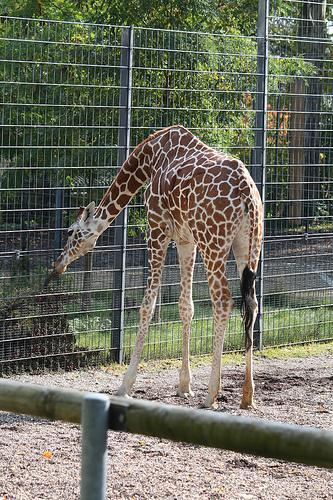Question: when was the photo taken?
Choices:
A. At night.
B. During the day.
C. In the morning.
D. At midnight.
Answer with the letter. Answer: B Question: what is the giraffe standing on?
Choices:
A. Rocks.
B. The dirt.
C. Grass.
D. Twigs.
Answer with the letter. Answer: B Question: what is the giraffe standing by?
Choices:
A. The door.
B. A fence.
C. The bear.
D. A rock.
Answer with the letter. Answer: B Question: how many giraffes are there?
Choices:
A. 4.
B. 6.
C. 1.
D. 7.
Answer with the letter. Answer: C Question: who is with the giraffe?
Choices:
A. Nobody.
B. The girls.
C. The feeder.
D. The keeper.
Answer with the letter. Answer: A Question: why is the giraffe doing?
Choices:
A. Sitting.
B. Eating a leaf.
C. Standing.
D. Walking.
Answer with the letter. Answer: B 